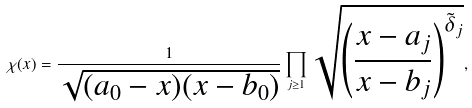Convert formula to latex. <formula><loc_0><loc_0><loc_500><loc_500>\chi ( x ) = \frac { 1 } { \sqrt { ( a _ { 0 } - x ) ( x - b _ { 0 } ) } } \prod _ { j \geq 1 } \sqrt { \left ( \frac { x - a _ { j } } { x - b _ { j } } \right ) ^ { \tilde { \delta } _ { j } } } ,</formula> 